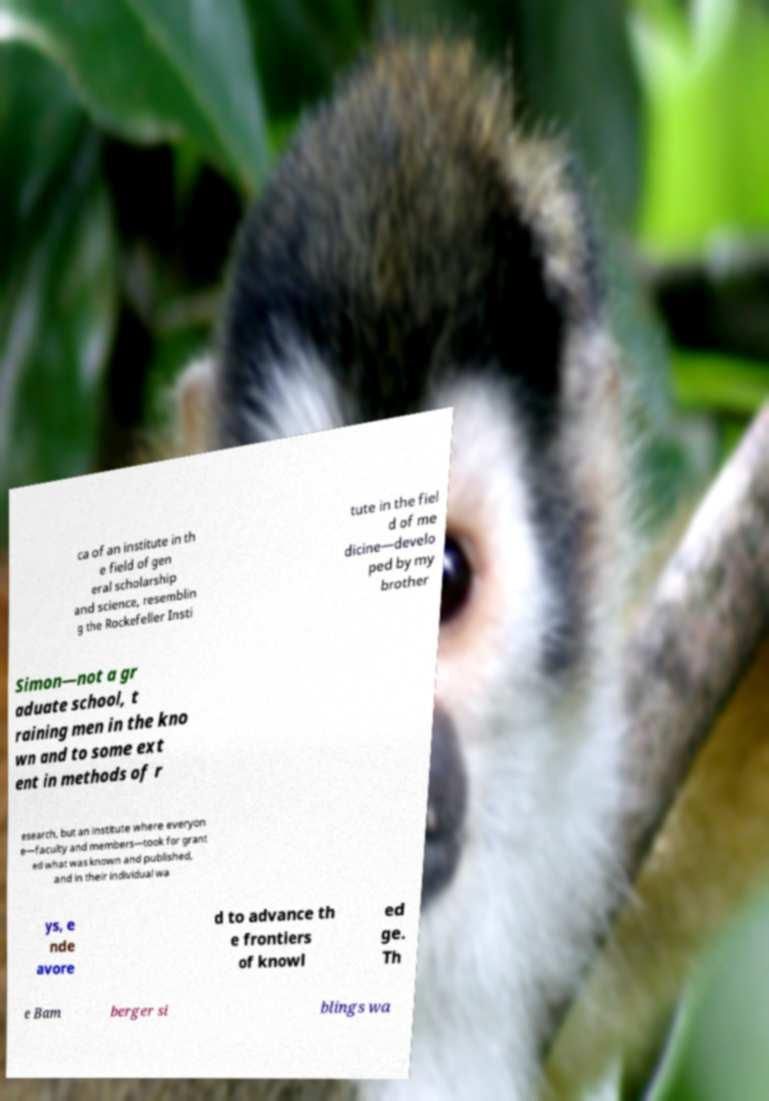Can you read and provide the text displayed in the image?This photo seems to have some interesting text. Can you extract and type it out for me? ca of an institute in th e field of gen eral scholarship and science, resemblin g the Rockefeller Insti tute in the fiel d of me dicine—develo ped by my brother Simon—not a gr aduate school, t raining men in the kno wn and to some ext ent in methods of r esearch, but an institute where everyon e—faculty and members—took for grant ed what was known and published, and in their individual wa ys, e nde avore d to advance th e frontiers of knowl ed ge. Th e Bam berger si blings wa 